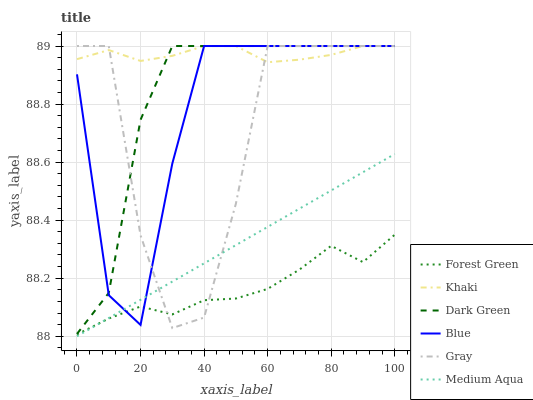Does Forest Green have the minimum area under the curve?
Answer yes or no. Yes. Does Khaki have the maximum area under the curve?
Answer yes or no. Yes. Does Gray have the minimum area under the curve?
Answer yes or no. No. Does Gray have the maximum area under the curve?
Answer yes or no. No. Is Medium Aqua the smoothest?
Answer yes or no. Yes. Is Gray the roughest?
Answer yes or no. Yes. Is Khaki the smoothest?
Answer yes or no. No. Is Khaki the roughest?
Answer yes or no. No. Does Medium Aqua have the lowest value?
Answer yes or no. Yes. Does Gray have the lowest value?
Answer yes or no. No. Does Dark Green have the highest value?
Answer yes or no. Yes. Does Forest Green have the highest value?
Answer yes or no. No. Is Forest Green less than Khaki?
Answer yes or no. Yes. Is Khaki greater than Forest Green?
Answer yes or no. Yes. Does Forest Green intersect Blue?
Answer yes or no. Yes. Is Forest Green less than Blue?
Answer yes or no. No. Is Forest Green greater than Blue?
Answer yes or no. No. Does Forest Green intersect Khaki?
Answer yes or no. No. 